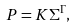Convert formula to latex. <formula><loc_0><loc_0><loc_500><loc_500>P = K \Sigma ^ { \Gamma } ,</formula> 